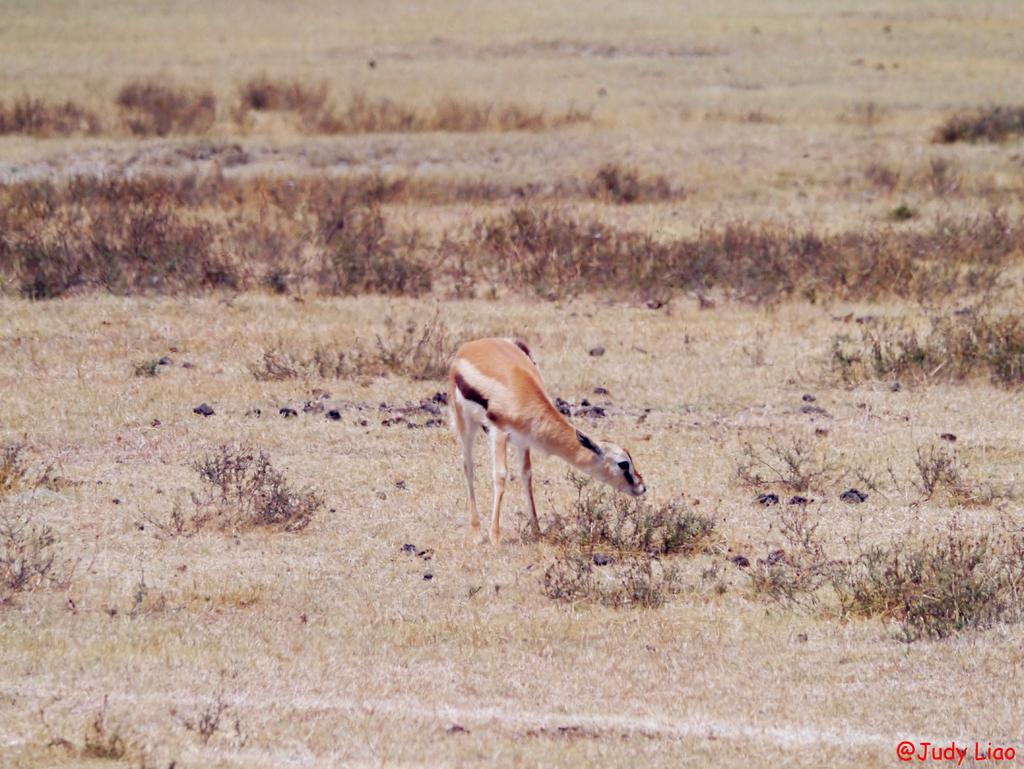What type of area is depicted in the image? There is an open ground in the image. What can be seen standing on the ground? There is a brown-colored door standing on the ground. What type of vegetation is visible in the image? Grass is visible in the image. Can you describe any additional features of the image? There is a watermark in the image. What advice does the grandmother give during the argument in the image? There is no grandmother or argument present in the image. 